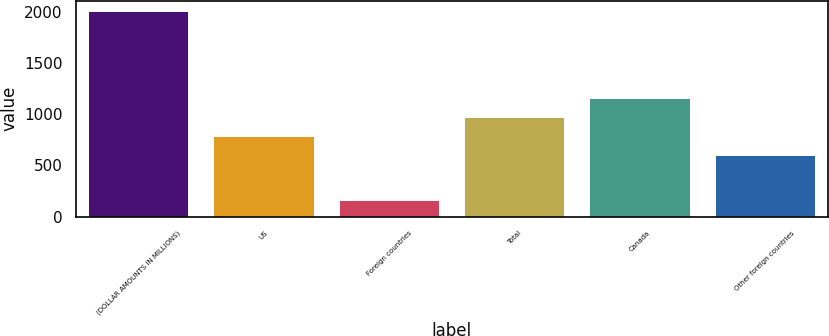<chart> <loc_0><loc_0><loc_500><loc_500><bar_chart><fcel>(DOLLAR AMOUNTS IN MILLIONS)<fcel>US<fcel>Foreign countries<fcel>Total<fcel>Canada<fcel>Other foreign countries<nl><fcel>2009<fcel>790.6<fcel>163<fcel>975.2<fcel>1159.8<fcel>606<nl></chart> 